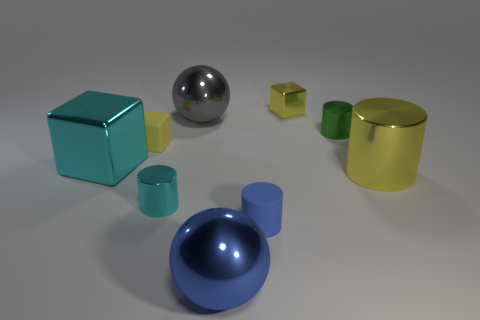Is the number of large gray metallic spheres on the left side of the small green metallic object greater than the number of cylinders to the right of the tiny rubber cylinder?
Your answer should be very brief. No. There is a yellow cylinder that is made of the same material as the green cylinder; what size is it?
Your answer should be compact. Large. What size is the yellow shiny thing that is behind the small cylinder behind the metal cylinder that is to the left of the blue metal ball?
Your answer should be compact. Small. What is the color of the sphere behind the green shiny thing?
Provide a succinct answer. Gray. Are there more yellow cubes in front of the blue metal object than small cyan metal cylinders?
Ensure brevity in your answer.  No. There is a yellow metallic thing in front of the big cyan object; is its shape the same as the green object?
Offer a terse response. Yes. What number of green objects are either balls or large shiny cylinders?
Keep it short and to the point. 0. Is the number of small yellow metal objects greater than the number of blocks?
Give a very brief answer. No. There is another shiny sphere that is the same size as the gray shiny ball; what color is it?
Provide a short and direct response. Blue. What number of cylinders are small objects or big objects?
Your response must be concise. 4. 